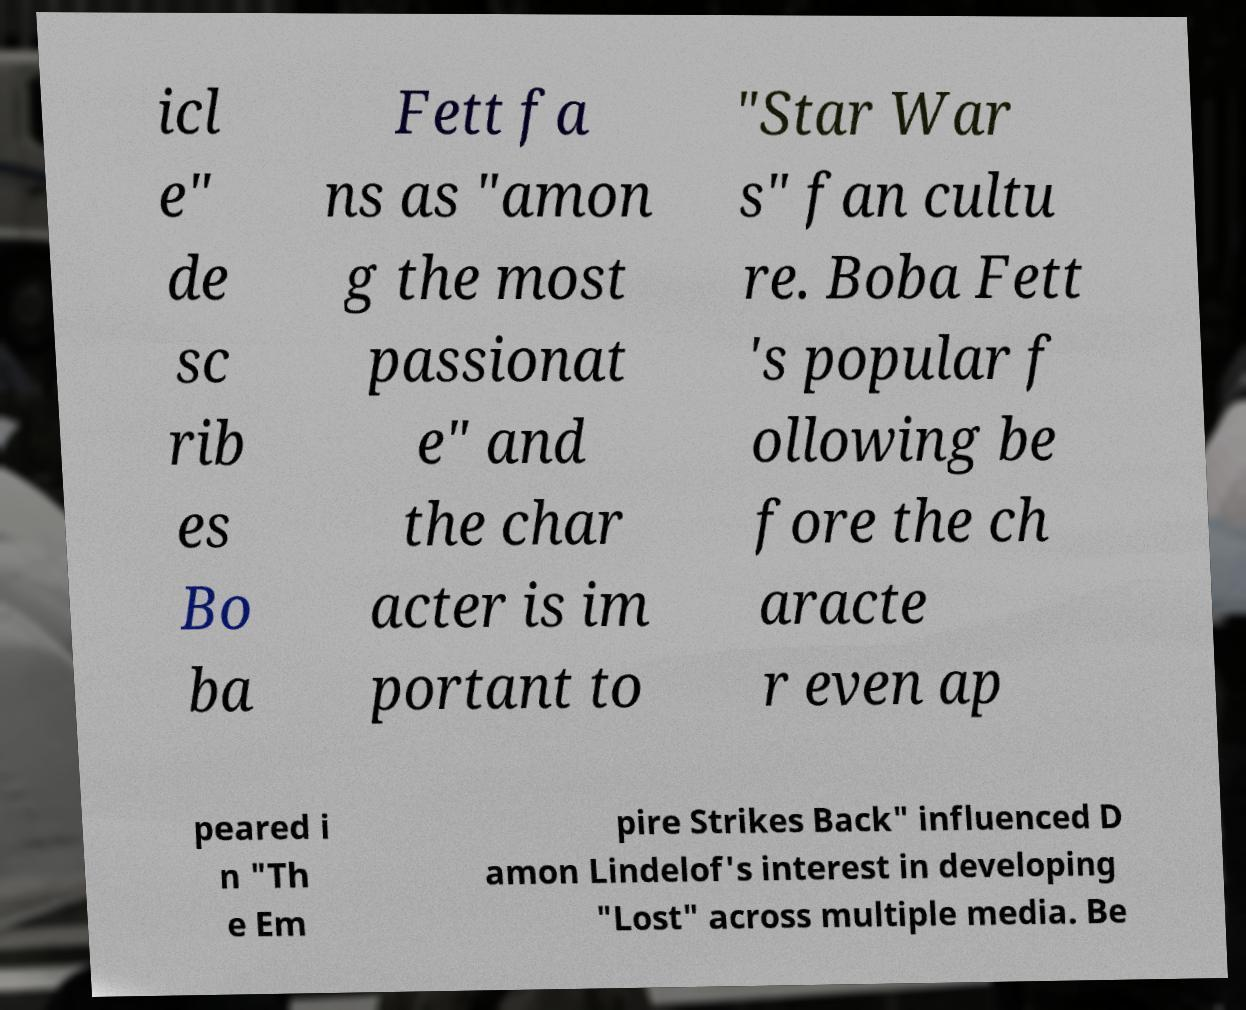For documentation purposes, I need the text within this image transcribed. Could you provide that? icl e" de sc rib es Bo ba Fett fa ns as "amon g the most passionat e" and the char acter is im portant to "Star War s" fan cultu re. Boba Fett 's popular f ollowing be fore the ch aracte r even ap peared i n "Th e Em pire Strikes Back" influenced D amon Lindelof's interest in developing "Lost" across multiple media. Be 